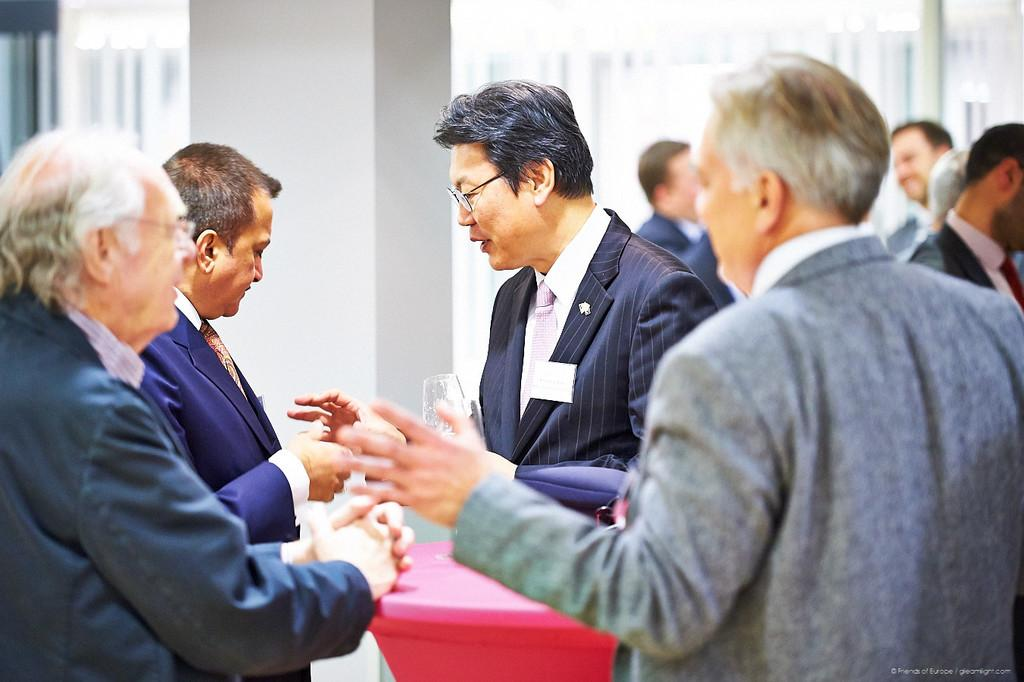What are the persons in the image wearing? The persons in the image are wearing suits. What object is being held by one of the persons in the image? There is a person holding a glass in the image. What can be seen in the background of the image? There is a pillar and a table covered with a cloth in the background of the image. What type of blade is being used by the person in the image? There is no blade present in the image; the person is holding a glass. 